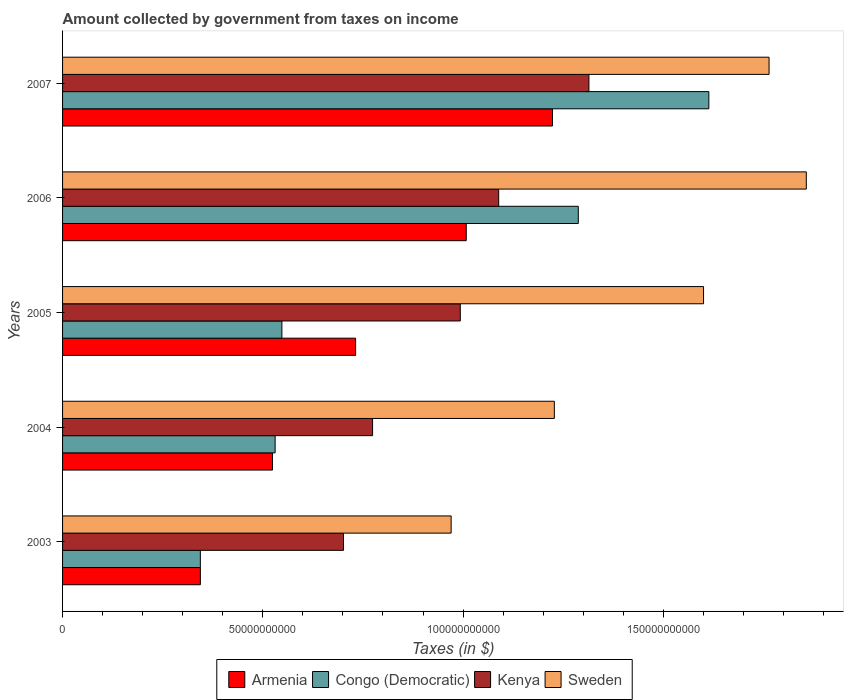How many different coloured bars are there?
Give a very brief answer. 4. What is the label of the 4th group of bars from the top?
Your answer should be compact. 2004. In how many cases, is the number of bars for a given year not equal to the number of legend labels?
Give a very brief answer. 0. What is the amount collected by government from taxes on income in Congo (Democratic) in 2005?
Make the answer very short. 5.48e+1. Across all years, what is the maximum amount collected by government from taxes on income in Armenia?
Keep it short and to the point. 1.22e+11. Across all years, what is the minimum amount collected by government from taxes on income in Armenia?
Provide a short and direct response. 3.44e+1. In which year was the amount collected by government from taxes on income in Kenya maximum?
Offer a very short reply. 2007. In which year was the amount collected by government from taxes on income in Congo (Democratic) minimum?
Keep it short and to the point. 2003. What is the total amount collected by government from taxes on income in Sweden in the graph?
Your response must be concise. 7.42e+11. What is the difference between the amount collected by government from taxes on income in Sweden in 2004 and that in 2005?
Offer a very short reply. -3.73e+1. What is the difference between the amount collected by government from taxes on income in Kenya in 2006 and the amount collected by government from taxes on income in Congo (Democratic) in 2007?
Your response must be concise. -5.25e+1. What is the average amount collected by government from taxes on income in Sweden per year?
Offer a very short reply. 1.48e+11. In the year 2007, what is the difference between the amount collected by government from taxes on income in Congo (Democratic) and amount collected by government from taxes on income in Sweden?
Give a very brief answer. -1.50e+1. In how many years, is the amount collected by government from taxes on income in Kenya greater than 10000000000 $?
Offer a very short reply. 5. What is the ratio of the amount collected by government from taxes on income in Armenia in 2006 to that in 2007?
Give a very brief answer. 0.82. What is the difference between the highest and the second highest amount collected by government from taxes on income in Congo (Democratic)?
Ensure brevity in your answer.  3.26e+1. What is the difference between the highest and the lowest amount collected by government from taxes on income in Congo (Democratic)?
Provide a succinct answer. 1.27e+11. In how many years, is the amount collected by government from taxes on income in Congo (Democratic) greater than the average amount collected by government from taxes on income in Congo (Democratic) taken over all years?
Your response must be concise. 2. Is the sum of the amount collected by government from taxes on income in Armenia in 2005 and 2006 greater than the maximum amount collected by government from taxes on income in Sweden across all years?
Your answer should be very brief. No. Is it the case that in every year, the sum of the amount collected by government from taxes on income in Kenya and amount collected by government from taxes on income in Armenia is greater than the sum of amount collected by government from taxes on income in Sweden and amount collected by government from taxes on income in Congo (Democratic)?
Offer a terse response. No. What does the 4th bar from the top in 2004 represents?
Your answer should be very brief. Armenia. What does the 4th bar from the bottom in 2005 represents?
Give a very brief answer. Sweden. Is it the case that in every year, the sum of the amount collected by government from taxes on income in Sweden and amount collected by government from taxes on income in Kenya is greater than the amount collected by government from taxes on income in Armenia?
Your response must be concise. Yes. How many years are there in the graph?
Ensure brevity in your answer.  5. What is the difference between two consecutive major ticks on the X-axis?
Provide a succinct answer. 5.00e+1. Are the values on the major ticks of X-axis written in scientific E-notation?
Your answer should be compact. No. Does the graph contain any zero values?
Provide a succinct answer. No. How are the legend labels stacked?
Keep it short and to the point. Horizontal. What is the title of the graph?
Your answer should be compact. Amount collected by government from taxes on income. Does "Yemen, Rep." appear as one of the legend labels in the graph?
Provide a short and direct response. No. What is the label or title of the X-axis?
Your answer should be compact. Taxes (in $). What is the Taxes (in $) in Armenia in 2003?
Offer a very short reply. 3.44e+1. What is the Taxes (in $) in Congo (Democratic) in 2003?
Make the answer very short. 3.44e+1. What is the Taxes (in $) of Kenya in 2003?
Provide a short and direct response. 7.01e+1. What is the Taxes (in $) of Sweden in 2003?
Keep it short and to the point. 9.70e+1. What is the Taxes (in $) of Armenia in 2004?
Your answer should be compact. 5.24e+1. What is the Taxes (in $) in Congo (Democratic) in 2004?
Give a very brief answer. 5.31e+1. What is the Taxes (in $) in Kenya in 2004?
Provide a short and direct response. 7.74e+1. What is the Taxes (in $) in Sweden in 2004?
Your answer should be very brief. 1.23e+11. What is the Taxes (in $) of Armenia in 2005?
Offer a terse response. 7.32e+1. What is the Taxes (in $) of Congo (Democratic) in 2005?
Keep it short and to the point. 5.48e+1. What is the Taxes (in $) in Kenya in 2005?
Give a very brief answer. 9.93e+1. What is the Taxes (in $) of Sweden in 2005?
Provide a short and direct response. 1.60e+11. What is the Taxes (in $) of Armenia in 2006?
Offer a terse response. 1.01e+11. What is the Taxes (in $) in Congo (Democratic) in 2006?
Offer a terse response. 1.29e+11. What is the Taxes (in $) in Kenya in 2006?
Offer a terse response. 1.09e+11. What is the Taxes (in $) of Sweden in 2006?
Make the answer very short. 1.86e+11. What is the Taxes (in $) of Armenia in 2007?
Provide a short and direct response. 1.22e+11. What is the Taxes (in $) of Congo (Democratic) in 2007?
Give a very brief answer. 1.61e+11. What is the Taxes (in $) in Kenya in 2007?
Give a very brief answer. 1.31e+11. What is the Taxes (in $) of Sweden in 2007?
Your answer should be compact. 1.76e+11. Across all years, what is the maximum Taxes (in $) of Armenia?
Your answer should be very brief. 1.22e+11. Across all years, what is the maximum Taxes (in $) of Congo (Democratic)?
Give a very brief answer. 1.61e+11. Across all years, what is the maximum Taxes (in $) in Kenya?
Offer a very short reply. 1.31e+11. Across all years, what is the maximum Taxes (in $) in Sweden?
Make the answer very short. 1.86e+11. Across all years, what is the minimum Taxes (in $) of Armenia?
Offer a very short reply. 3.44e+1. Across all years, what is the minimum Taxes (in $) in Congo (Democratic)?
Your answer should be compact. 3.44e+1. Across all years, what is the minimum Taxes (in $) of Kenya?
Your answer should be very brief. 7.01e+1. Across all years, what is the minimum Taxes (in $) in Sweden?
Offer a terse response. 9.70e+1. What is the total Taxes (in $) in Armenia in the graph?
Make the answer very short. 3.83e+11. What is the total Taxes (in $) of Congo (Democratic) in the graph?
Your answer should be very brief. 4.32e+11. What is the total Taxes (in $) in Kenya in the graph?
Ensure brevity in your answer.  4.87e+11. What is the total Taxes (in $) of Sweden in the graph?
Your response must be concise. 7.42e+11. What is the difference between the Taxes (in $) in Armenia in 2003 and that in 2004?
Offer a terse response. -1.80e+1. What is the difference between the Taxes (in $) of Congo (Democratic) in 2003 and that in 2004?
Your answer should be very brief. -1.87e+1. What is the difference between the Taxes (in $) in Kenya in 2003 and that in 2004?
Your answer should be compact. -7.27e+09. What is the difference between the Taxes (in $) in Sweden in 2003 and that in 2004?
Your answer should be very brief. -2.58e+1. What is the difference between the Taxes (in $) of Armenia in 2003 and that in 2005?
Offer a terse response. -3.88e+1. What is the difference between the Taxes (in $) in Congo (Democratic) in 2003 and that in 2005?
Ensure brevity in your answer.  -2.04e+1. What is the difference between the Taxes (in $) of Kenya in 2003 and that in 2005?
Provide a short and direct response. -2.92e+1. What is the difference between the Taxes (in $) in Sweden in 2003 and that in 2005?
Offer a very short reply. -6.30e+1. What is the difference between the Taxes (in $) in Armenia in 2003 and that in 2006?
Your answer should be compact. -6.64e+1. What is the difference between the Taxes (in $) in Congo (Democratic) in 2003 and that in 2006?
Ensure brevity in your answer.  -9.44e+1. What is the difference between the Taxes (in $) in Kenya in 2003 and that in 2006?
Keep it short and to the point. -3.88e+1. What is the difference between the Taxes (in $) of Sweden in 2003 and that in 2006?
Your answer should be compact. -8.87e+1. What is the difference between the Taxes (in $) in Armenia in 2003 and that in 2007?
Offer a very short reply. -8.79e+1. What is the difference between the Taxes (in $) of Congo (Democratic) in 2003 and that in 2007?
Offer a very short reply. -1.27e+11. What is the difference between the Taxes (in $) in Kenya in 2003 and that in 2007?
Give a very brief answer. -6.13e+1. What is the difference between the Taxes (in $) in Sweden in 2003 and that in 2007?
Provide a short and direct response. -7.94e+1. What is the difference between the Taxes (in $) of Armenia in 2004 and that in 2005?
Provide a succinct answer. -2.07e+1. What is the difference between the Taxes (in $) of Congo (Democratic) in 2004 and that in 2005?
Offer a terse response. -1.69e+09. What is the difference between the Taxes (in $) in Kenya in 2004 and that in 2005?
Provide a short and direct response. -2.19e+1. What is the difference between the Taxes (in $) in Sweden in 2004 and that in 2005?
Give a very brief answer. -3.73e+1. What is the difference between the Taxes (in $) in Armenia in 2004 and that in 2006?
Provide a short and direct response. -4.84e+1. What is the difference between the Taxes (in $) of Congo (Democratic) in 2004 and that in 2006?
Provide a short and direct response. -7.57e+1. What is the difference between the Taxes (in $) in Kenya in 2004 and that in 2006?
Offer a terse response. -3.15e+1. What is the difference between the Taxes (in $) of Sweden in 2004 and that in 2006?
Your response must be concise. -6.29e+1. What is the difference between the Taxes (in $) of Armenia in 2004 and that in 2007?
Give a very brief answer. -6.99e+1. What is the difference between the Taxes (in $) in Congo (Democratic) in 2004 and that in 2007?
Keep it short and to the point. -1.08e+11. What is the difference between the Taxes (in $) of Kenya in 2004 and that in 2007?
Keep it short and to the point. -5.40e+1. What is the difference between the Taxes (in $) in Sweden in 2004 and that in 2007?
Your answer should be compact. -5.36e+1. What is the difference between the Taxes (in $) in Armenia in 2005 and that in 2006?
Provide a succinct answer. -2.76e+1. What is the difference between the Taxes (in $) in Congo (Democratic) in 2005 and that in 2006?
Ensure brevity in your answer.  -7.40e+1. What is the difference between the Taxes (in $) of Kenya in 2005 and that in 2006?
Provide a succinct answer. -9.59e+09. What is the difference between the Taxes (in $) of Sweden in 2005 and that in 2006?
Offer a very short reply. -2.57e+1. What is the difference between the Taxes (in $) of Armenia in 2005 and that in 2007?
Your answer should be very brief. -4.92e+1. What is the difference between the Taxes (in $) of Congo (Democratic) in 2005 and that in 2007?
Make the answer very short. -1.07e+11. What is the difference between the Taxes (in $) of Kenya in 2005 and that in 2007?
Provide a succinct answer. -3.21e+1. What is the difference between the Taxes (in $) in Sweden in 2005 and that in 2007?
Provide a succinct answer. -1.64e+1. What is the difference between the Taxes (in $) in Armenia in 2006 and that in 2007?
Give a very brief answer. -2.15e+1. What is the difference between the Taxes (in $) of Congo (Democratic) in 2006 and that in 2007?
Your answer should be compact. -3.26e+1. What is the difference between the Taxes (in $) of Kenya in 2006 and that in 2007?
Provide a succinct answer. -2.25e+1. What is the difference between the Taxes (in $) of Sweden in 2006 and that in 2007?
Keep it short and to the point. 9.30e+09. What is the difference between the Taxes (in $) of Armenia in 2003 and the Taxes (in $) of Congo (Democratic) in 2004?
Your response must be concise. -1.87e+1. What is the difference between the Taxes (in $) of Armenia in 2003 and the Taxes (in $) of Kenya in 2004?
Offer a very short reply. -4.30e+1. What is the difference between the Taxes (in $) of Armenia in 2003 and the Taxes (in $) of Sweden in 2004?
Offer a very short reply. -8.84e+1. What is the difference between the Taxes (in $) in Congo (Democratic) in 2003 and the Taxes (in $) in Kenya in 2004?
Offer a terse response. -4.30e+1. What is the difference between the Taxes (in $) of Congo (Democratic) in 2003 and the Taxes (in $) of Sweden in 2004?
Your answer should be compact. -8.84e+1. What is the difference between the Taxes (in $) of Kenya in 2003 and the Taxes (in $) of Sweden in 2004?
Provide a succinct answer. -5.27e+1. What is the difference between the Taxes (in $) of Armenia in 2003 and the Taxes (in $) of Congo (Democratic) in 2005?
Your response must be concise. -2.04e+1. What is the difference between the Taxes (in $) in Armenia in 2003 and the Taxes (in $) in Kenya in 2005?
Offer a terse response. -6.49e+1. What is the difference between the Taxes (in $) of Armenia in 2003 and the Taxes (in $) of Sweden in 2005?
Provide a succinct answer. -1.26e+11. What is the difference between the Taxes (in $) of Congo (Democratic) in 2003 and the Taxes (in $) of Kenya in 2005?
Give a very brief answer. -6.49e+1. What is the difference between the Taxes (in $) in Congo (Democratic) in 2003 and the Taxes (in $) in Sweden in 2005?
Make the answer very short. -1.26e+11. What is the difference between the Taxes (in $) of Kenya in 2003 and the Taxes (in $) of Sweden in 2005?
Keep it short and to the point. -8.99e+1. What is the difference between the Taxes (in $) in Armenia in 2003 and the Taxes (in $) in Congo (Democratic) in 2006?
Make the answer very short. -9.44e+1. What is the difference between the Taxes (in $) of Armenia in 2003 and the Taxes (in $) of Kenya in 2006?
Offer a terse response. -7.45e+1. What is the difference between the Taxes (in $) of Armenia in 2003 and the Taxes (in $) of Sweden in 2006?
Your response must be concise. -1.51e+11. What is the difference between the Taxes (in $) in Congo (Democratic) in 2003 and the Taxes (in $) in Kenya in 2006?
Offer a terse response. -7.45e+1. What is the difference between the Taxes (in $) of Congo (Democratic) in 2003 and the Taxes (in $) of Sweden in 2006?
Provide a succinct answer. -1.51e+11. What is the difference between the Taxes (in $) in Kenya in 2003 and the Taxes (in $) in Sweden in 2006?
Your answer should be very brief. -1.16e+11. What is the difference between the Taxes (in $) in Armenia in 2003 and the Taxes (in $) in Congo (Democratic) in 2007?
Offer a very short reply. -1.27e+11. What is the difference between the Taxes (in $) of Armenia in 2003 and the Taxes (in $) of Kenya in 2007?
Keep it short and to the point. -9.70e+1. What is the difference between the Taxes (in $) in Armenia in 2003 and the Taxes (in $) in Sweden in 2007?
Your answer should be very brief. -1.42e+11. What is the difference between the Taxes (in $) in Congo (Democratic) in 2003 and the Taxes (in $) in Kenya in 2007?
Ensure brevity in your answer.  -9.70e+1. What is the difference between the Taxes (in $) in Congo (Democratic) in 2003 and the Taxes (in $) in Sweden in 2007?
Provide a short and direct response. -1.42e+11. What is the difference between the Taxes (in $) of Kenya in 2003 and the Taxes (in $) of Sweden in 2007?
Ensure brevity in your answer.  -1.06e+11. What is the difference between the Taxes (in $) of Armenia in 2004 and the Taxes (in $) of Congo (Democratic) in 2005?
Give a very brief answer. -2.34e+09. What is the difference between the Taxes (in $) in Armenia in 2004 and the Taxes (in $) in Kenya in 2005?
Make the answer very short. -4.69e+1. What is the difference between the Taxes (in $) in Armenia in 2004 and the Taxes (in $) in Sweden in 2005?
Your response must be concise. -1.08e+11. What is the difference between the Taxes (in $) of Congo (Democratic) in 2004 and the Taxes (in $) of Kenya in 2005?
Provide a short and direct response. -4.62e+1. What is the difference between the Taxes (in $) in Congo (Democratic) in 2004 and the Taxes (in $) in Sweden in 2005?
Ensure brevity in your answer.  -1.07e+11. What is the difference between the Taxes (in $) of Kenya in 2004 and the Taxes (in $) of Sweden in 2005?
Provide a succinct answer. -8.26e+1. What is the difference between the Taxes (in $) in Armenia in 2004 and the Taxes (in $) in Congo (Democratic) in 2006?
Your answer should be very brief. -7.63e+1. What is the difference between the Taxes (in $) of Armenia in 2004 and the Taxes (in $) of Kenya in 2006?
Provide a succinct answer. -5.65e+1. What is the difference between the Taxes (in $) of Armenia in 2004 and the Taxes (in $) of Sweden in 2006?
Your answer should be very brief. -1.33e+11. What is the difference between the Taxes (in $) in Congo (Democratic) in 2004 and the Taxes (in $) in Kenya in 2006?
Your answer should be compact. -5.58e+1. What is the difference between the Taxes (in $) in Congo (Democratic) in 2004 and the Taxes (in $) in Sweden in 2006?
Ensure brevity in your answer.  -1.33e+11. What is the difference between the Taxes (in $) in Kenya in 2004 and the Taxes (in $) in Sweden in 2006?
Offer a very short reply. -1.08e+11. What is the difference between the Taxes (in $) of Armenia in 2004 and the Taxes (in $) of Congo (Democratic) in 2007?
Your answer should be very brief. -1.09e+11. What is the difference between the Taxes (in $) in Armenia in 2004 and the Taxes (in $) in Kenya in 2007?
Your response must be concise. -7.90e+1. What is the difference between the Taxes (in $) of Armenia in 2004 and the Taxes (in $) of Sweden in 2007?
Ensure brevity in your answer.  -1.24e+11. What is the difference between the Taxes (in $) of Congo (Democratic) in 2004 and the Taxes (in $) of Kenya in 2007?
Ensure brevity in your answer.  -7.84e+1. What is the difference between the Taxes (in $) of Congo (Democratic) in 2004 and the Taxes (in $) of Sweden in 2007?
Provide a succinct answer. -1.23e+11. What is the difference between the Taxes (in $) of Kenya in 2004 and the Taxes (in $) of Sweden in 2007?
Offer a very short reply. -9.90e+1. What is the difference between the Taxes (in $) in Armenia in 2005 and the Taxes (in $) in Congo (Democratic) in 2006?
Your answer should be compact. -5.56e+1. What is the difference between the Taxes (in $) of Armenia in 2005 and the Taxes (in $) of Kenya in 2006?
Make the answer very short. -3.57e+1. What is the difference between the Taxes (in $) of Armenia in 2005 and the Taxes (in $) of Sweden in 2006?
Provide a short and direct response. -1.13e+11. What is the difference between the Taxes (in $) of Congo (Democratic) in 2005 and the Taxes (in $) of Kenya in 2006?
Your response must be concise. -5.41e+1. What is the difference between the Taxes (in $) in Congo (Democratic) in 2005 and the Taxes (in $) in Sweden in 2006?
Your answer should be very brief. -1.31e+11. What is the difference between the Taxes (in $) of Kenya in 2005 and the Taxes (in $) of Sweden in 2006?
Your answer should be very brief. -8.64e+1. What is the difference between the Taxes (in $) in Armenia in 2005 and the Taxes (in $) in Congo (Democratic) in 2007?
Provide a short and direct response. -8.82e+1. What is the difference between the Taxes (in $) of Armenia in 2005 and the Taxes (in $) of Kenya in 2007?
Offer a very short reply. -5.83e+1. What is the difference between the Taxes (in $) in Armenia in 2005 and the Taxes (in $) in Sweden in 2007?
Give a very brief answer. -1.03e+11. What is the difference between the Taxes (in $) in Congo (Democratic) in 2005 and the Taxes (in $) in Kenya in 2007?
Provide a succinct answer. -7.67e+1. What is the difference between the Taxes (in $) of Congo (Democratic) in 2005 and the Taxes (in $) of Sweden in 2007?
Provide a succinct answer. -1.22e+11. What is the difference between the Taxes (in $) of Kenya in 2005 and the Taxes (in $) of Sweden in 2007?
Offer a terse response. -7.71e+1. What is the difference between the Taxes (in $) of Armenia in 2006 and the Taxes (in $) of Congo (Democratic) in 2007?
Provide a short and direct response. -6.06e+1. What is the difference between the Taxes (in $) of Armenia in 2006 and the Taxes (in $) of Kenya in 2007?
Provide a succinct answer. -3.06e+1. What is the difference between the Taxes (in $) in Armenia in 2006 and the Taxes (in $) in Sweden in 2007?
Keep it short and to the point. -7.56e+1. What is the difference between the Taxes (in $) in Congo (Democratic) in 2006 and the Taxes (in $) in Kenya in 2007?
Your answer should be very brief. -2.65e+09. What is the difference between the Taxes (in $) of Congo (Democratic) in 2006 and the Taxes (in $) of Sweden in 2007?
Ensure brevity in your answer.  -4.76e+1. What is the difference between the Taxes (in $) of Kenya in 2006 and the Taxes (in $) of Sweden in 2007?
Provide a succinct answer. -6.75e+1. What is the average Taxes (in $) of Armenia per year?
Give a very brief answer. 7.66e+1. What is the average Taxes (in $) in Congo (Democratic) per year?
Provide a succinct answer. 8.65e+1. What is the average Taxes (in $) in Kenya per year?
Offer a terse response. 9.74e+1. What is the average Taxes (in $) of Sweden per year?
Your response must be concise. 1.48e+11. In the year 2003, what is the difference between the Taxes (in $) in Armenia and Taxes (in $) in Congo (Democratic)?
Provide a succinct answer. 6.10e+06. In the year 2003, what is the difference between the Taxes (in $) in Armenia and Taxes (in $) in Kenya?
Make the answer very short. -3.57e+1. In the year 2003, what is the difference between the Taxes (in $) of Armenia and Taxes (in $) of Sweden?
Offer a terse response. -6.26e+1. In the year 2003, what is the difference between the Taxes (in $) in Congo (Democratic) and Taxes (in $) in Kenya?
Ensure brevity in your answer.  -3.57e+1. In the year 2003, what is the difference between the Taxes (in $) of Congo (Democratic) and Taxes (in $) of Sweden?
Offer a terse response. -6.26e+1. In the year 2003, what is the difference between the Taxes (in $) of Kenya and Taxes (in $) of Sweden?
Ensure brevity in your answer.  -2.69e+1. In the year 2004, what is the difference between the Taxes (in $) in Armenia and Taxes (in $) in Congo (Democratic)?
Your answer should be very brief. -6.52e+08. In the year 2004, what is the difference between the Taxes (in $) in Armenia and Taxes (in $) in Kenya?
Offer a terse response. -2.50e+1. In the year 2004, what is the difference between the Taxes (in $) in Armenia and Taxes (in $) in Sweden?
Offer a terse response. -7.04e+1. In the year 2004, what is the difference between the Taxes (in $) in Congo (Democratic) and Taxes (in $) in Kenya?
Your response must be concise. -2.43e+1. In the year 2004, what is the difference between the Taxes (in $) in Congo (Democratic) and Taxes (in $) in Sweden?
Offer a terse response. -6.97e+1. In the year 2004, what is the difference between the Taxes (in $) of Kenya and Taxes (in $) of Sweden?
Your answer should be very brief. -4.54e+1. In the year 2005, what is the difference between the Taxes (in $) in Armenia and Taxes (in $) in Congo (Democratic)?
Make the answer very short. 1.84e+1. In the year 2005, what is the difference between the Taxes (in $) in Armenia and Taxes (in $) in Kenya?
Provide a short and direct response. -2.61e+1. In the year 2005, what is the difference between the Taxes (in $) of Armenia and Taxes (in $) of Sweden?
Offer a very short reply. -8.69e+1. In the year 2005, what is the difference between the Taxes (in $) of Congo (Democratic) and Taxes (in $) of Kenya?
Make the answer very short. -4.45e+1. In the year 2005, what is the difference between the Taxes (in $) in Congo (Democratic) and Taxes (in $) in Sweden?
Your answer should be compact. -1.05e+11. In the year 2005, what is the difference between the Taxes (in $) in Kenya and Taxes (in $) in Sweden?
Your answer should be very brief. -6.07e+1. In the year 2006, what is the difference between the Taxes (in $) in Armenia and Taxes (in $) in Congo (Democratic)?
Offer a terse response. -2.80e+1. In the year 2006, what is the difference between the Taxes (in $) of Armenia and Taxes (in $) of Kenya?
Offer a terse response. -8.10e+09. In the year 2006, what is the difference between the Taxes (in $) of Armenia and Taxes (in $) of Sweden?
Offer a terse response. -8.49e+1. In the year 2006, what is the difference between the Taxes (in $) in Congo (Democratic) and Taxes (in $) in Kenya?
Offer a very short reply. 1.99e+1. In the year 2006, what is the difference between the Taxes (in $) of Congo (Democratic) and Taxes (in $) of Sweden?
Offer a very short reply. -5.69e+1. In the year 2006, what is the difference between the Taxes (in $) of Kenya and Taxes (in $) of Sweden?
Provide a succinct answer. -7.68e+1. In the year 2007, what is the difference between the Taxes (in $) of Armenia and Taxes (in $) of Congo (Democratic)?
Provide a succinct answer. -3.90e+1. In the year 2007, what is the difference between the Taxes (in $) of Armenia and Taxes (in $) of Kenya?
Ensure brevity in your answer.  -9.09e+09. In the year 2007, what is the difference between the Taxes (in $) in Armenia and Taxes (in $) in Sweden?
Give a very brief answer. -5.41e+1. In the year 2007, what is the difference between the Taxes (in $) of Congo (Democratic) and Taxes (in $) of Kenya?
Offer a very short reply. 2.99e+1. In the year 2007, what is the difference between the Taxes (in $) of Congo (Democratic) and Taxes (in $) of Sweden?
Offer a terse response. -1.50e+1. In the year 2007, what is the difference between the Taxes (in $) in Kenya and Taxes (in $) in Sweden?
Your answer should be compact. -4.50e+1. What is the ratio of the Taxes (in $) of Armenia in 2003 to that in 2004?
Your answer should be compact. 0.66. What is the ratio of the Taxes (in $) of Congo (Democratic) in 2003 to that in 2004?
Your answer should be compact. 0.65. What is the ratio of the Taxes (in $) in Kenya in 2003 to that in 2004?
Make the answer very short. 0.91. What is the ratio of the Taxes (in $) in Sweden in 2003 to that in 2004?
Keep it short and to the point. 0.79. What is the ratio of the Taxes (in $) in Armenia in 2003 to that in 2005?
Provide a succinct answer. 0.47. What is the ratio of the Taxes (in $) of Congo (Democratic) in 2003 to that in 2005?
Give a very brief answer. 0.63. What is the ratio of the Taxes (in $) of Kenya in 2003 to that in 2005?
Ensure brevity in your answer.  0.71. What is the ratio of the Taxes (in $) of Sweden in 2003 to that in 2005?
Provide a short and direct response. 0.61. What is the ratio of the Taxes (in $) of Armenia in 2003 to that in 2006?
Offer a very short reply. 0.34. What is the ratio of the Taxes (in $) in Congo (Democratic) in 2003 to that in 2006?
Make the answer very short. 0.27. What is the ratio of the Taxes (in $) of Kenya in 2003 to that in 2006?
Give a very brief answer. 0.64. What is the ratio of the Taxes (in $) in Sweden in 2003 to that in 2006?
Your answer should be very brief. 0.52. What is the ratio of the Taxes (in $) in Armenia in 2003 to that in 2007?
Provide a succinct answer. 0.28. What is the ratio of the Taxes (in $) of Congo (Democratic) in 2003 to that in 2007?
Make the answer very short. 0.21. What is the ratio of the Taxes (in $) in Kenya in 2003 to that in 2007?
Your answer should be very brief. 0.53. What is the ratio of the Taxes (in $) of Sweden in 2003 to that in 2007?
Give a very brief answer. 0.55. What is the ratio of the Taxes (in $) in Armenia in 2004 to that in 2005?
Offer a very short reply. 0.72. What is the ratio of the Taxes (in $) in Congo (Democratic) in 2004 to that in 2005?
Provide a short and direct response. 0.97. What is the ratio of the Taxes (in $) of Kenya in 2004 to that in 2005?
Your response must be concise. 0.78. What is the ratio of the Taxes (in $) in Sweden in 2004 to that in 2005?
Your answer should be very brief. 0.77. What is the ratio of the Taxes (in $) in Armenia in 2004 to that in 2006?
Give a very brief answer. 0.52. What is the ratio of the Taxes (in $) in Congo (Democratic) in 2004 to that in 2006?
Your answer should be very brief. 0.41. What is the ratio of the Taxes (in $) of Kenya in 2004 to that in 2006?
Your response must be concise. 0.71. What is the ratio of the Taxes (in $) in Sweden in 2004 to that in 2006?
Offer a terse response. 0.66. What is the ratio of the Taxes (in $) of Armenia in 2004 to that in 2007?
Ensure brevity in your answer.  0.43. What is the ratio of the Taxes (in $) in Congo (Democratic) in 2004 to that in 2007?
Ensure brevity in your answer.  0.33. What is the ratio of the Taxes (in $) of Kenya in 2004 to that in 2007?
Your response must be concise. 0.59. What is the ratio of the Taxes (in $) in Sweden in 2004 to that in 2007?
Keep it short and to the point. 0.7. What is the ratio of the Taxes (in $) in Armenia in 2005 to that in 2006?
Provide a succinct answer. 0.73. What is the ratio of the Taxes (in $) in Congo (Democratic) in 2005 to that in 2006?
Your answer should be very brief. 0.43. What is the ratio of the Taxes (in $) in Kenya in 2005 to that in 2006?
Make the answer very short. 0.91. What is the ratio of the Taxes (in $) in Sweden in 2005 to that in 2006?
Offer a terse response. 0.86. What is the ratio of the Taxes (in $) in Armenia in 2005 to that in 2007?
Provide a short and direct response. 0.6. What is the ratio of the Taxes (in $) in Congo (Democratic) in 2005 to that in 2007?
Make the answer very short. 0.34. What is the ratio of the Taxes (in $) in Kenya in 2005 to that in 2007?
Ensure brevity in your answer.  0.76. What is the ratio of the Taxes (in $) of Sweden in 2005 to that in 2007?
Ensure brevity in your answer.  0.91. What is the ratio of the Taxes (in $) in Armenia in 2006 to that in 2007?
Offer a terse response. 0.82. What is the ratio of the Taxes (in $) in Congo (Democratic) in 2006 to that in 2007?
Your answer should be very brief. 0.8. What is the ratio of the Taxes (in $) of Kenya in 2006 to that in 2007?
Offer a very short reply. 0.83. What is the ratio of the Taxes (in $) of Sweden in 2006 to that in 2007?
Ensure brevity in your answer.  1.05. What is the difference between the highest and the second highest Taxes (in $) in Armenia?
Offer a terse response. 2.15e+1. What is the difference between the highest and the second highest Taxes (in $) of Congo (Democratic)?
Your answer should be compact. 3.26e+1. What is the difference between the highest and the second highest Taxes (in $) in Kenya?
Make the answer very short. 2.25e+1. What is the difference between the highest and the second highest Taxes (in $) of Sweden?
Keep it short and to the point. 9.30e+09. What is the difference between the highest and the lowest Taxes (in $) in Armenia?
Make the answer very short. 8.79e+1. What is the difference between the highest and the lowest Taxes (in $) in Congo (Democratic)?
Offer a terse response. 1.27e+11. What is the difference between the highest and the lowest Taxes (in $) in Kenya?
Ensure brevity in your answer.  6.13e+1. What is the difference between the highest and the lowest Taxes (in $) of Sweden?
Your answer should be compact. 8.87e+1. 